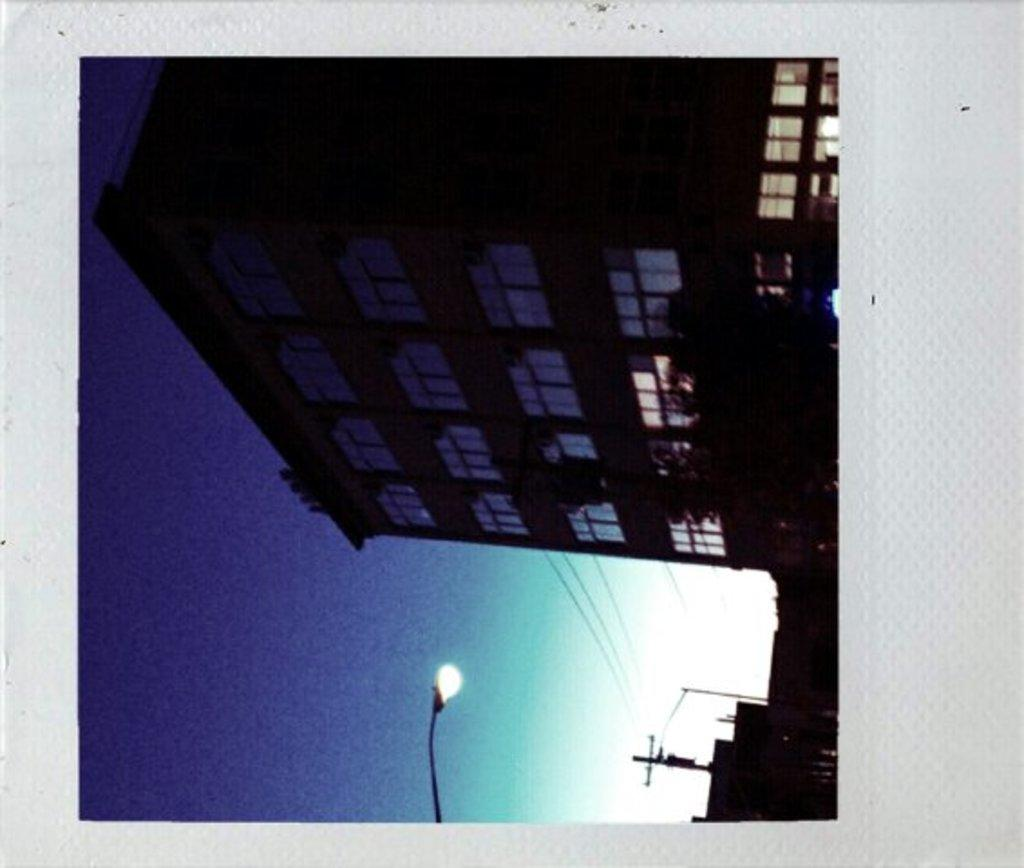What type of structure is visible in the picture? There is a building in the picture. What else can be seen in the picture besides the building? There is an electricity pole and a street light pole in the picture. What is the condition of the sky in the picture? The sky is clear in the picture. What type of leather material is used for the chairs in the image? There are no chairs present in the image, so it's not possible to determine the type of leather material used. What is the copper content of the electricity pole in the image? There is no information about the composition of the electricity pole, so it's not possible to determine the copper content. 